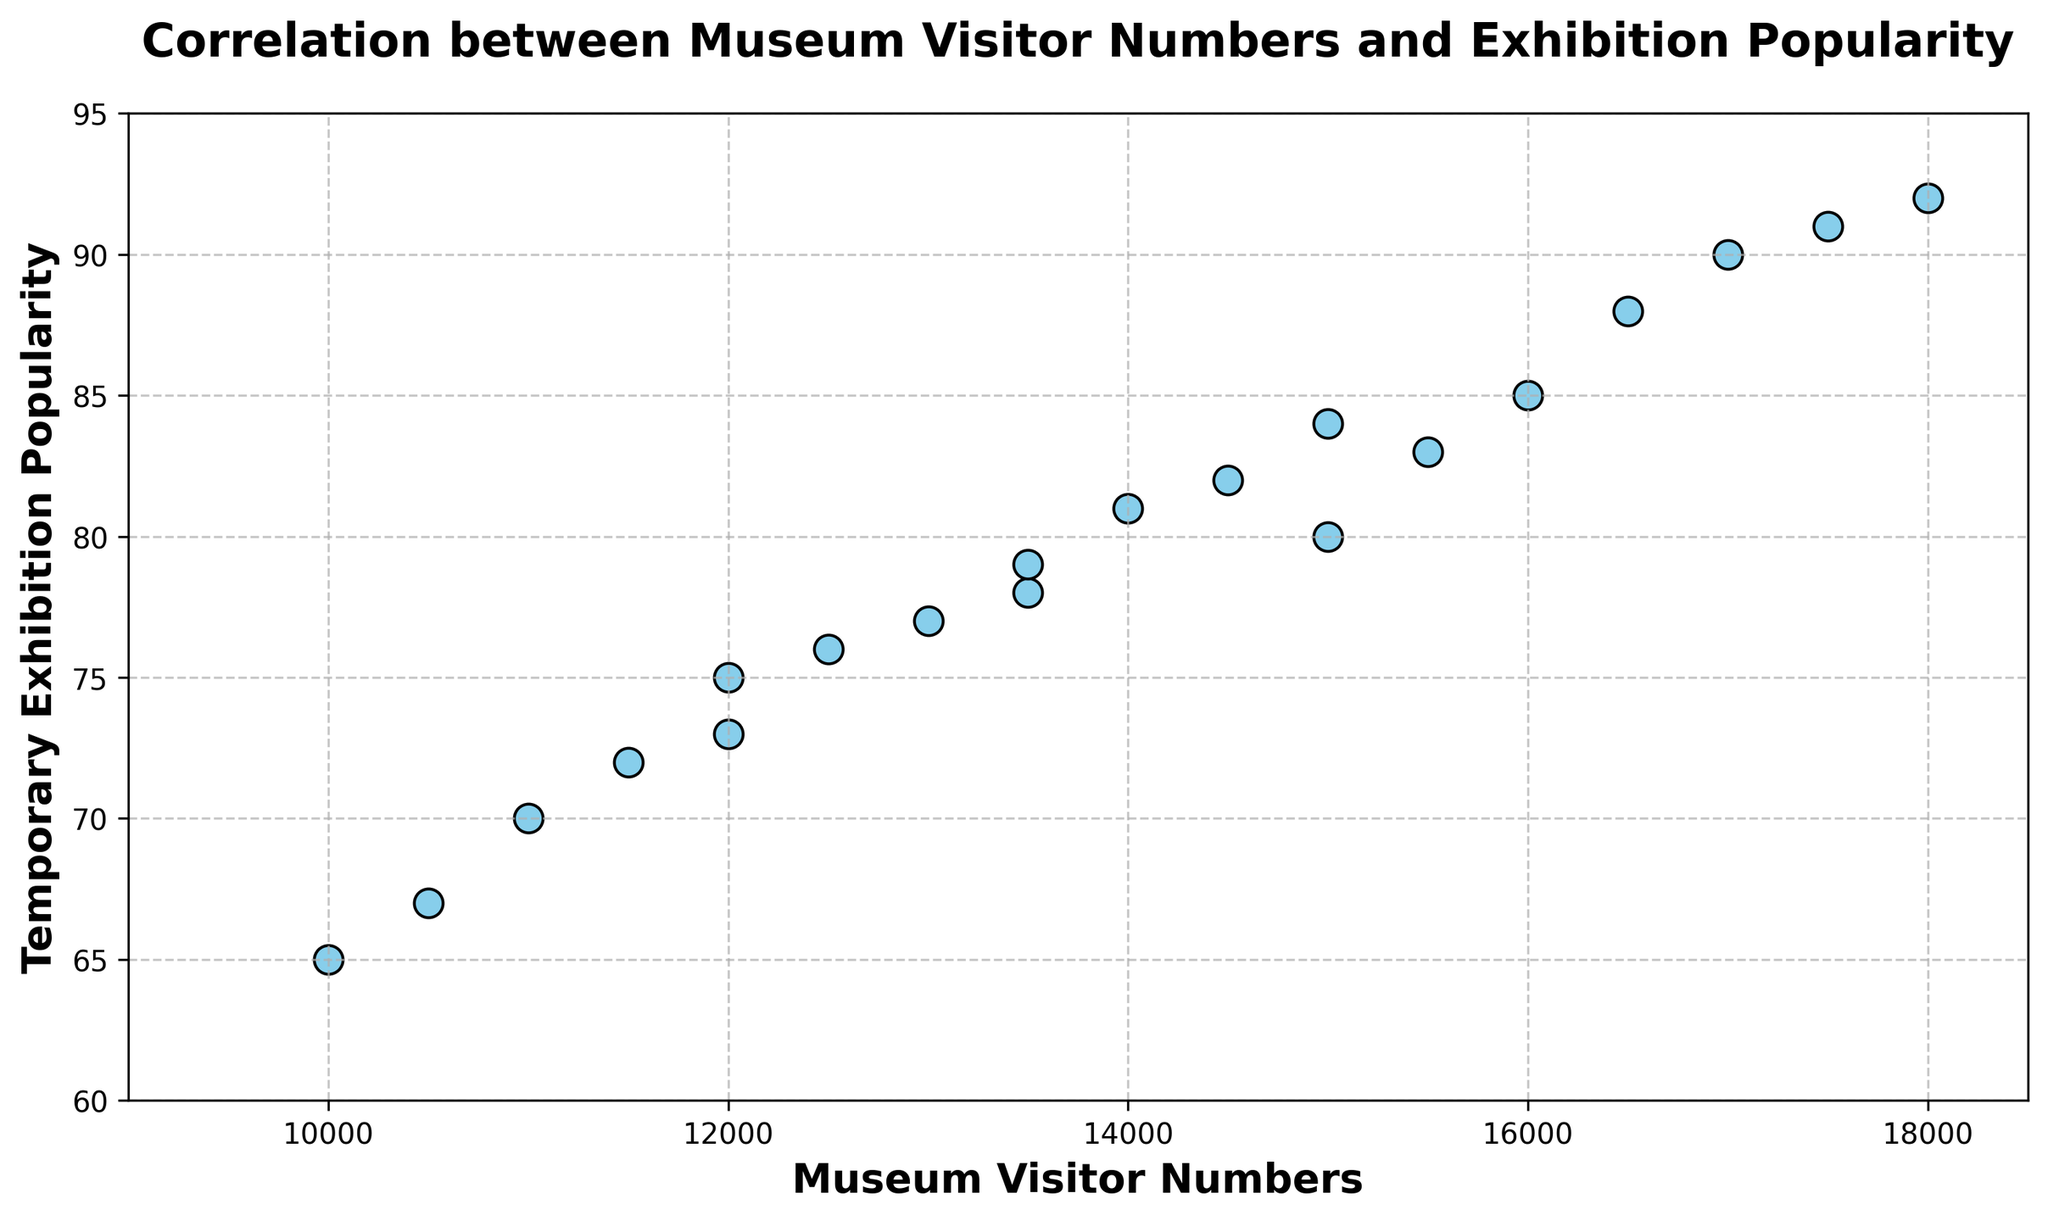What is the range of Museum Visitor Numbers depicted in the plot? The x-axis depicts the range of Museum Visitor Numbers. The lowest value starts at 10,000 and the highest value goes up to 18,000.
Answer: 10,000 to 18,000 How many data points are there in the scatter plot? Each point on the scatter plot represents a data point. By visually counting them, we see there are 20 points.
Answer: 20 Which Museum Visitor Numbers correspond to a Temporary Exhibition Popularity of 85? Locate the y-axis value 85, then trace horizontally to the points on the plot. Two points correspond to Museum Visitor Numbers of 16,000 and 17,500.
Answer: 16,000 and 17,500 What is the average Temporary Exhibition Popularity for Museum Visitor Numbers of 15,000? Identify the points where Museum Visitor Numbers are 15,000 and find the corresponding y-axis values. The points align with Temporary Exhibition Popularity values of 80, 84, and their average is (80+84)/2 = 82
Answer: 82 Which data point shows the highest Temporary Exhibition Popularity, and what are its Museum Visitor Numbers? Identify the point that reaches the topmost of the y-axis. The highest popularity is 92, with Museum Visitor Numbers of 18,000.
Answer: 18,000 Is there a positive correlation between Museum Visitor Numbers and Temporary Exhibition Popularity based on the scatter plot? The points generally slope upwards from left to right, indicating a positive relationship between the variables.
Answer: Yes Which Museum Visitor Numbers show a Temporary Exhibition Popularity of less than 70? Find points below y-axis value 70 and check corresponding x-axis values. The points correspond with Museum Visitor Numbers of 10,000 and 10,500.
Answer: 10,000 and 10,500 What is the difference in Museum Visitor Numbers for data points with Temporary Exhibition Popularity values of 70 and 90? Locate the points where y-axis values are 70 and 90, corresponding to Museum Visitor Numbers of 11,000 and 17,000. The difference is 17,000 - 11,000 = 6,000.
Answer: 6,000 Which is greater, the average Museum Visitor Numbers for Temporary Exhibition Popularity of 70 or 80? Average the Visitor Numbers for Popularity of 70 and 80 values. The points are 11,000 for 70 and 15,000 for both 80 points, average for 70 is 11,000, and for 80 is (15,000 + 15,000)/2 = 15,000.
Answer: 80 Is there any point with exactly 12,000 Museum Visitor Numbers and its associated Temporary Exhibition Popularity? Locate the point at x-axis value 12,000, which shows y-axis values 75 and 73.
Answer: 75 and 73 